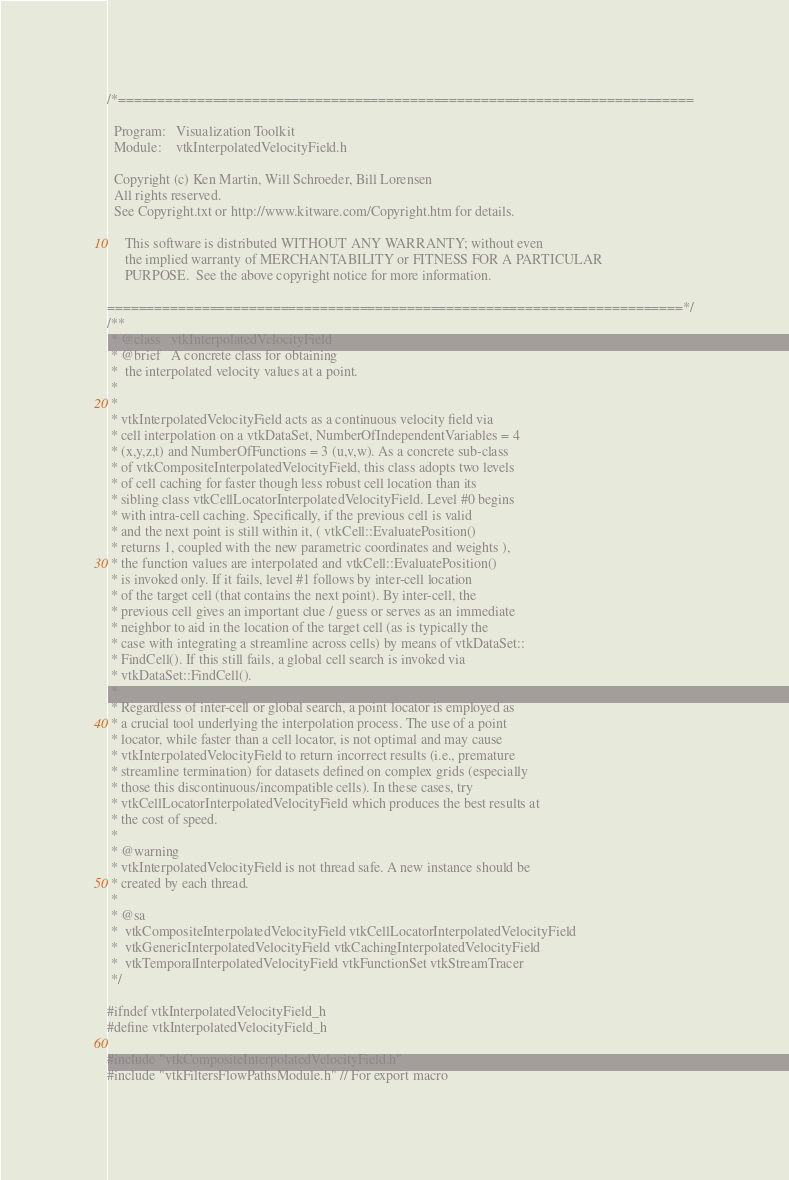<code> <loc_0><loc_0><loc_500><loc_500><_C_>/*=========================================================================

  Program:   Visualization Toolkit
  Module:    vtkInterpolatedVelocityField.h

  Copyright (c) Ken Martin, Will Schroeder, Bill Lorensen
  All rights reserved.
  See Copyright.txt or http://www.kitware.com/Copyright.htm for details.

     This software is distributed WITHOUT ANY WARRANTY; without even
     the implied warranty of MERCHANTABILITY or FITNESS FOR A PARTICULAR
     PURPOSE.  See the above copyright notice for more information.

=========================================================================*/
/**
 * @class   vtkInterpolatedVelocityField
 * @brief   A concrete class for obtaining
 *  the interpolated velocity values at a point.
 *
 *
 * vtkInterpolatedVelocityField acts as a continuous velocity field via
 * cell interpolation on a vtkDataSet, NumberOfIndependentVariables = 4
 * (x,y,z,t) and NumberOfFunctions = 3 (u,v,w). As a concrete sub-class
 * of vtkCompositeInterpolatedVelocityField, this class adopts two levels
 * of cell caching for faster though less robust cell location than its
 * sibling class vtkCellLocatorInterpolatedVelocityField. Level #0 begins
 * with intra-cell caching. Specifically, if the previous cell is valid
 * and the next point is still within it, ( vtkCell::EvaluatePosition()
 * returns 1, coupled with the new parametric coordinates and weights ),
 * the function values are interpolated and vtkCell::EvaluatePosition()
 * is invoked only. If it fails, level #1 follows by inter-cell location
 * of the target cell (that contains the next point). By inter-cell, the
 * previous cell gives an important clue / guess or serves as an immediate
 * neighbor to aid in the location of the target cell (as is typically the
 * case with integrating a streamline across cells) by means of vtkDataSet::
 * FindCell(). If this still fails, a global cell search is invoked via
 * vtkDataSet::FindCell().
 *
 * Regardless of inter-cell or global search, a point locator is employed as
 * a crucial tool underlying the interpolation process. The use of a point
 * locator, while faster than a cell locator, is not optimal and may cause
 * vtkInterpolatedVelocityField to return incorrect results (i.e., premature
 * streamline termination) for datasets defined on complex grids (especially
 * those this discontinuous/incompatible cells). In these cases, try
 * vtkCellLocatorInterpolatedVelocityField which produces the best results at
 * the cost of speed.
 *
 * @warning
 * vtkInterpolatedVelocityField is not thread safe. A new instance should be
 * created by each thread.
 *
 * @sa
 *  vtkCompositeInterpolatedVelocityField vtkCellLocatorInterpolatedVelocityField
 *  vtkGenericInterpolatedVelocityField vtkCachingInterpolatedVelocityField
 *  vtkTemporalInterpolatedVelocityField vtkFunctionSet vtkStreamTracer
 */

#ifndef vtkInterpolatedVelocityField_h
#define vtkInterpolatedVelocityField_h

#include "vtkCompositeInterpolatedVelocityField.h"
#include "vtkFiltersFlowPathsModule.h" // For export macro
</code> 